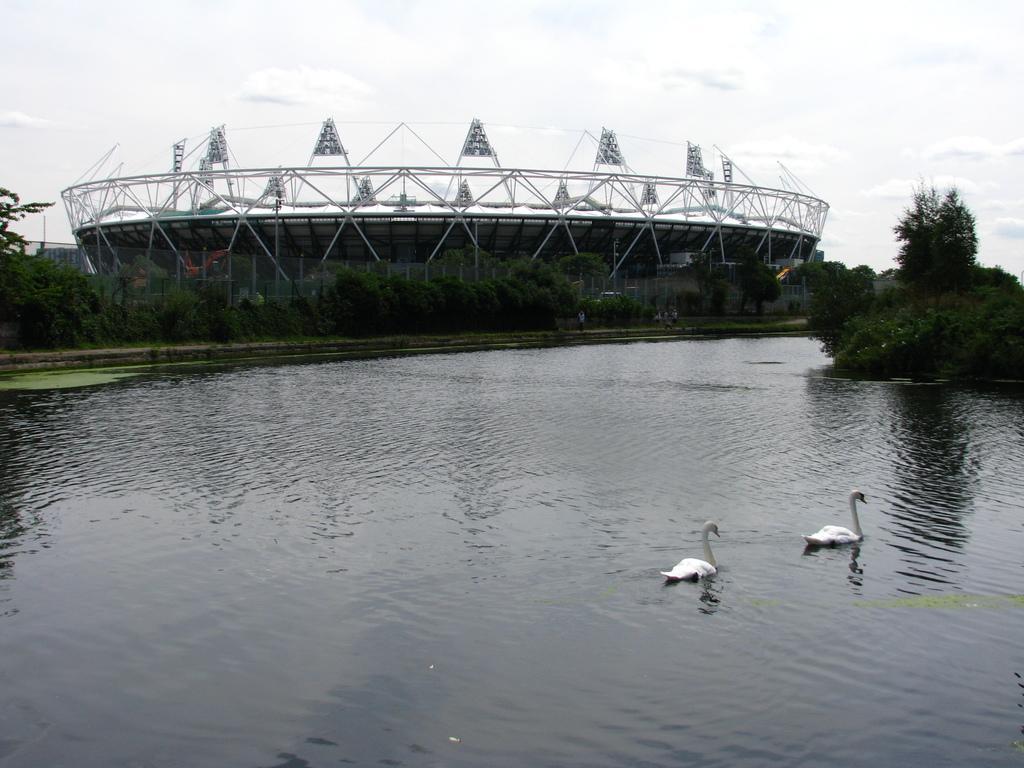How would you summarize this image in a sentence or two? In the background we can see the sky. In this picture we can see an architecture. We can see the trees, fence. We can also see the water and the swans. 